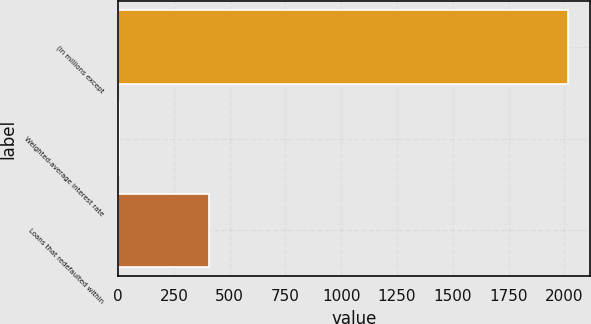Convert chart to OTSL. <chart><loc_0><loc_0><loc_500><loc_500><bar_chart><fcel>(in millions except<fcel>Weighted-average interest rate<fcel>Loans that redefaulted within<nl><fcel>2014<fcel>4.4<fcel>406.32<nl></chart> 